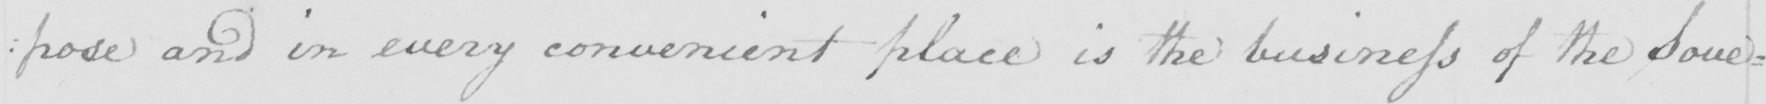Can you tell me what this handwritten text says? :pose and in every convenient place is the business of the Sove: 